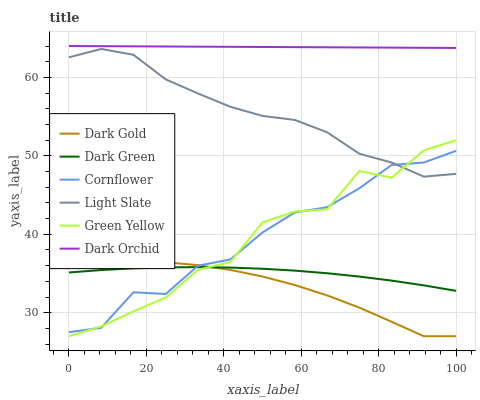Does Dark Gold have the minimum area under the curve?
Answer yes or no. Yes. Does Dark Orchid have the maximum area under the curve?
Answer yes or no. Yes. Does Light Slate have the minimum area under the curve?
Answer yes or no. No. Does Light Slate have the maximum area under the curve?
Answer yes or no. No. Is Dark Orchid the smoothest?
Answer yes or no. Yes. Is Green Yellow the roughest?
Answer yes or no. Yes. Is Dark Gold the smoothest?
Answer yes or no. No. Is Dark Gold the roughest?
Answer yes or no. No. Does Dark Gold have the lowest value?
Answer yes or no. Yes. Does Light Slate have the lowest value?
Answer yes or no. No. Does Dark Orchid have the highest value?
Answer yes or no. Yes. Does Dark Gold have the highest value?
Answer yes or no. No. Is Cornflower less than Dark Orchid?
Answer yes or no. Yes. Is Dark Orchid greater than Cornflower?
Answer yes or no. Yes. Does Dark Gold intersect Dark Green?
Answer yes or no. Yes. Is Dark Gold less than Dark Green?
Answer yes or no. No. Is Dark Gold greater than Dark Green?
Answer yes or no. No. Does Cornflower intersect Dark Orchid?
Answer yes or no. No. 